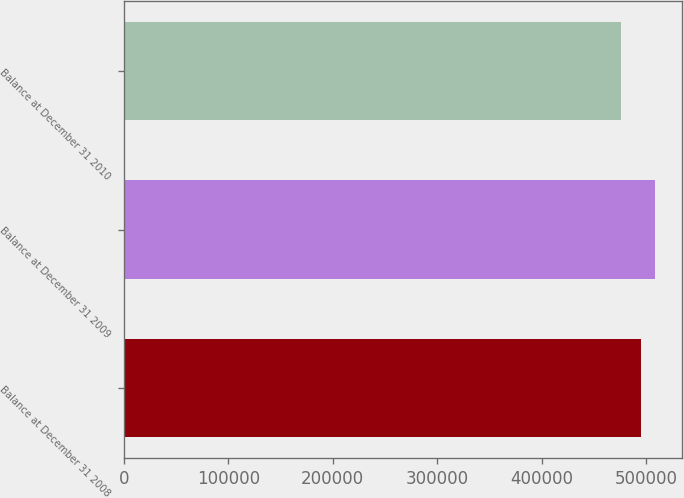Convert chart. <chart><loc_0><loc_0><loc_500><loc_500><bar_chart><fcel>Balance at December 31 2008<fcel>Balance at December 31 2009<fcel>Balance at December 31 2010<nl><fcel>495523<fcel>508650<fcel>475605<nl></chart> 